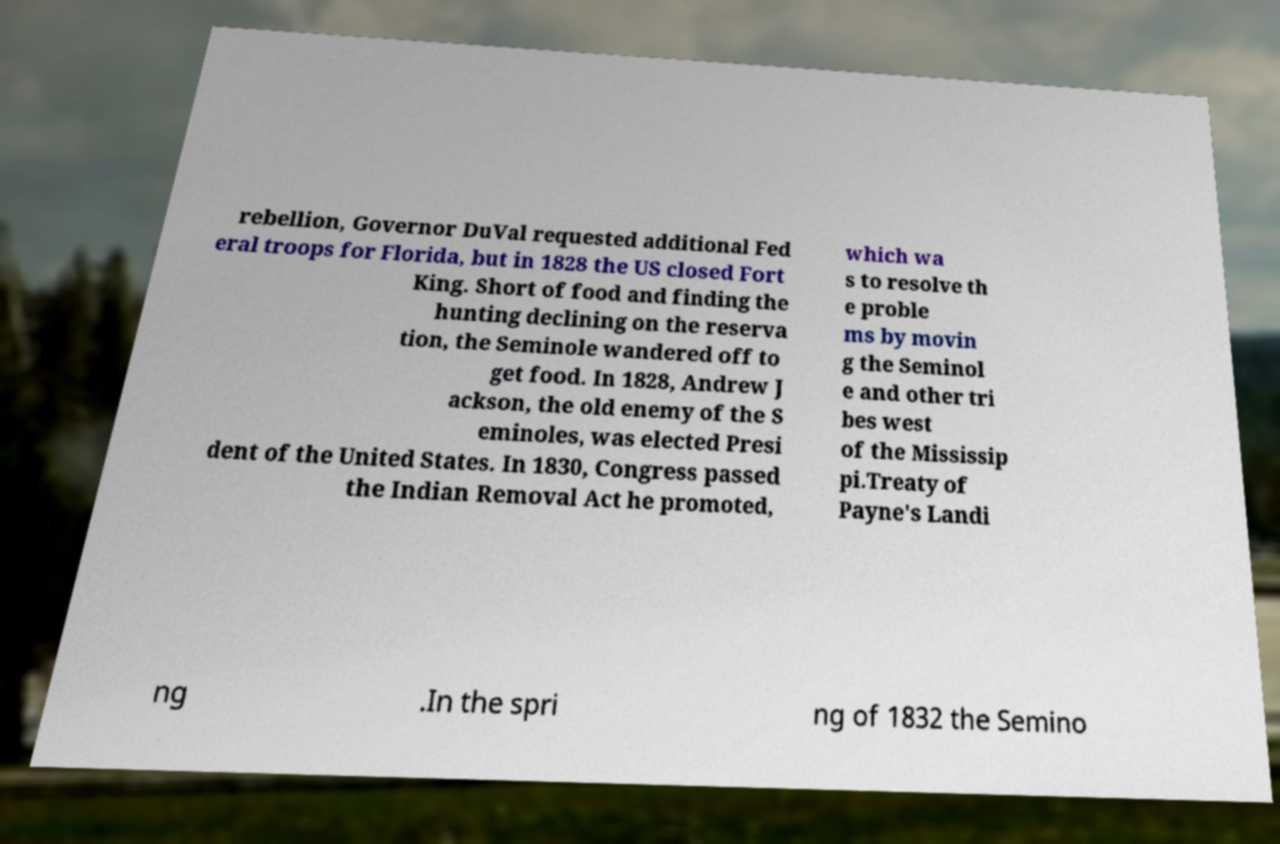Could you extract and type out the text from this image? rebellion, Governor DuVal requested additional Fed eral troops for Florida, but in 1828 the US closed Fort King. Short of food and finding the hunting declining on the reserva tion, the Seminole wandered off to get food. In 1828, Andrew J ackson, the old enemy of the S eminoles, was elected Presi dent of the United States. In 1830, Congress passed the Indian Removal Act he promoted, which wa s to resolve th e proble ms by movin g the Seminol e and other tri bes west of the Mississip pi.Treaty of Payne's Landi ng .In the spri ng of 1832 the Semino 